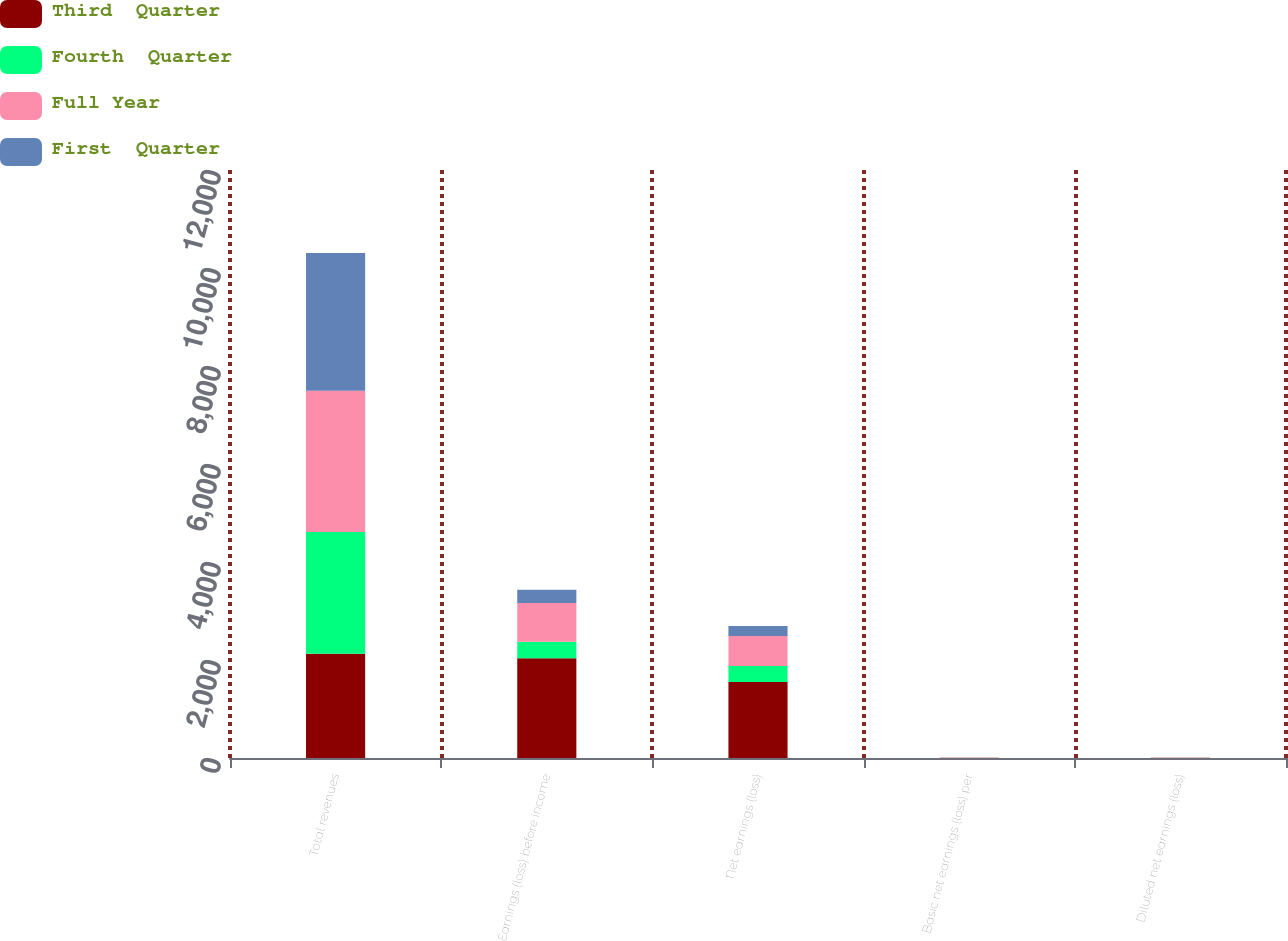<chart> <loc_0><loc_0><loc_500><loc_500><stacked_bar_chart><ecel><fcel>Total revenues<fcel>Earnings (loss) before income<fcel>Net earnings (loss)<fcel>Basic net earnings (loss) per<fcel>Diluted net earnings (loss)<nl><fcel>Third  Quarter<fcel>2126<fcel>2036<fcel>1550<fcel>3.27<fcel>3.27<nl><fcel>Fourth  Quarter<fcel>2488<fcel>339<fcel>326<fcel>0.63<fcel>0.63<nl><fcel>Full Year<fcel>2882<fcel>787<fcel>613<fcel>1.17<fcel>1.16<nl><fcel>First  Quarter<fcel>2808<fcel>271<fcel>207<fcel>0.41<fcel>0.41<nl></chart> 